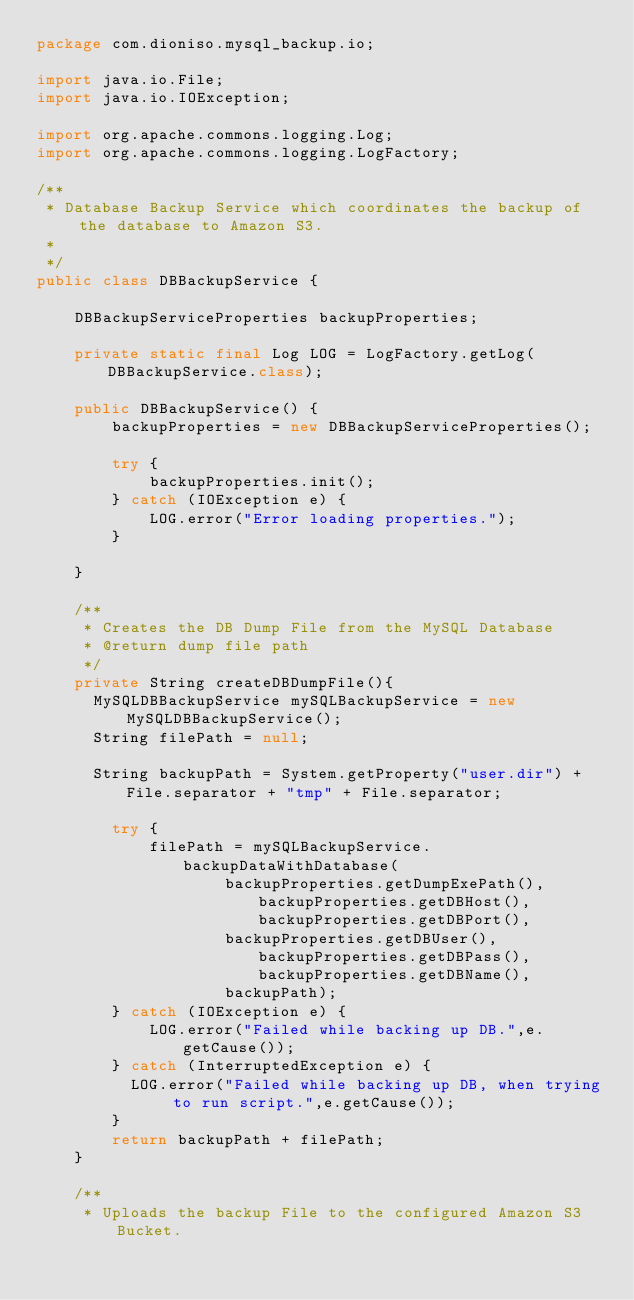<code> <loc_0><loc_0><loc_500><loc_500><_Java_>package com.dioniso.mysql_backup.io;

import java.io.File;
import java.io.IOException;

import org.apache.commons.logging.Log;
import org.apache.commons.logging.LogFactory;

/**
 * Database Backup Service which coordinates the backup of the database to Amazon S3.
 *
 */
public class DBBackupService {
    
    DBBackupServiceProperties backupProperties;
    
    private static final Log LOG = LogFactory.getLog(DBBackupService.class);
    
    public DBBackupService() {
        backupProperties = new DBBackupServiceProperties();
        
        try {
            backupProperties.init();
        } catch (IOException e) {
            LOG.error("Error loading properties.");
        }        
        
    }
    
    /**
     * Creates the DB Dump File from the MySQL Database
     * @return dump file path
     */
    private String createDBDumpFile(){
    	MySQLDBBackupService mySQLBackupService = new MySQLDBBackupService();
    	String filePath = null;
    	
    	String backupPath = System.getProperty("user.dir") + File.separator + "tmp" + File.separator;
        
        try {
            filePath = mySQLBackupService.backupDataWithDatabase(
                    backupProperties.getDumpExePath(), backupProperties.getDBHost(), backupProperties.getDBPort(), 
                    backupProperties.getDBUser(), backupProperties.getDBPass(), backupProperties.getDBName(), 
                    backupPath);            
        } catch (IOException e) {
            LOG.error("Failed while backing up DB.",e.getCause());
        } catch (InterruptedException e) {
        	LOG.error("Failed while backing up DB, when trying to run script.",e.getCause());
        }
        return backupPath + filePath;
    }
    
    /**
     * Uploads the backup File to the configured Amazon S3 Bucket.</code> 